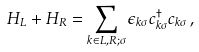Convert formula to latex. <formula><loc_0><loc_0><loc_500><loc_500>H _ { L } + H _ { R } = \sum _ { k \in L , R ; \sigma } \epsilon _ { k \sigma } c _ { k \sigma } ^ { \dagger } c _ { k \sigma } \, ,</formula> 